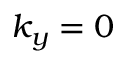Convert formula to latex. <formula><loc_0><loc_0><loc_500><loc_500>k _ { y } = 0</formula> 